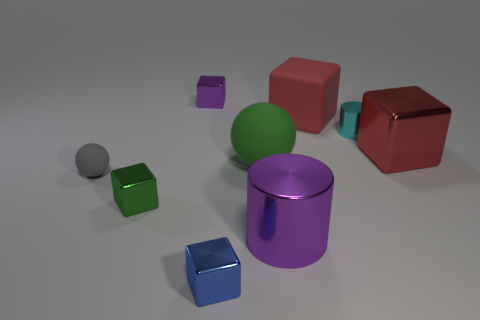There is a metal thing that is to the left of the tiny purple object; is it the same color as the small cylinder?
Your answer should be very brief. No. Are there any other things that have the same color as the tiny cylinder?
Your response must be concise. No. What color is the tiny metal object to the left of the purple thing on the left side of the purple metallic object that is to the right of the small blue block?
Your answer should be very brief. Green. Is the size of the cyan cylinder the same as the red metal thing?
Provide a short and direct response. No. What number of blue shiny objects are the same size as the green metal cube?
Give a very brief answer. 1. There is a thing that is the same color as the large ball; what is its shape?
Your response must be concise. Cube. Is the block in front of the green cube made of the same material as the ball to the right of the small gray matte thing?
Offer a terse response. No. Is there anything else that has the same shape as the red rubber object?
Offer a very short reply. Yes. The rubber block has what color?
Provide a succinct answer. Red. How many tiny gray rubber objects have the same shape as the small cyan thing?
Offer a very short reply. 0. 